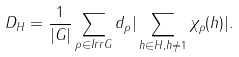Convert formula to latex. <formula><loc_0><loc_0><loc_500><loc_500>D _ { H } = \frac { 1 } { | G | } \sum _ { \rho \in I r r G } d _ { \rho } | \sum _ { h \in H , h \neq 1 } \chi _ { \rho } ( h ) | .</formula> 